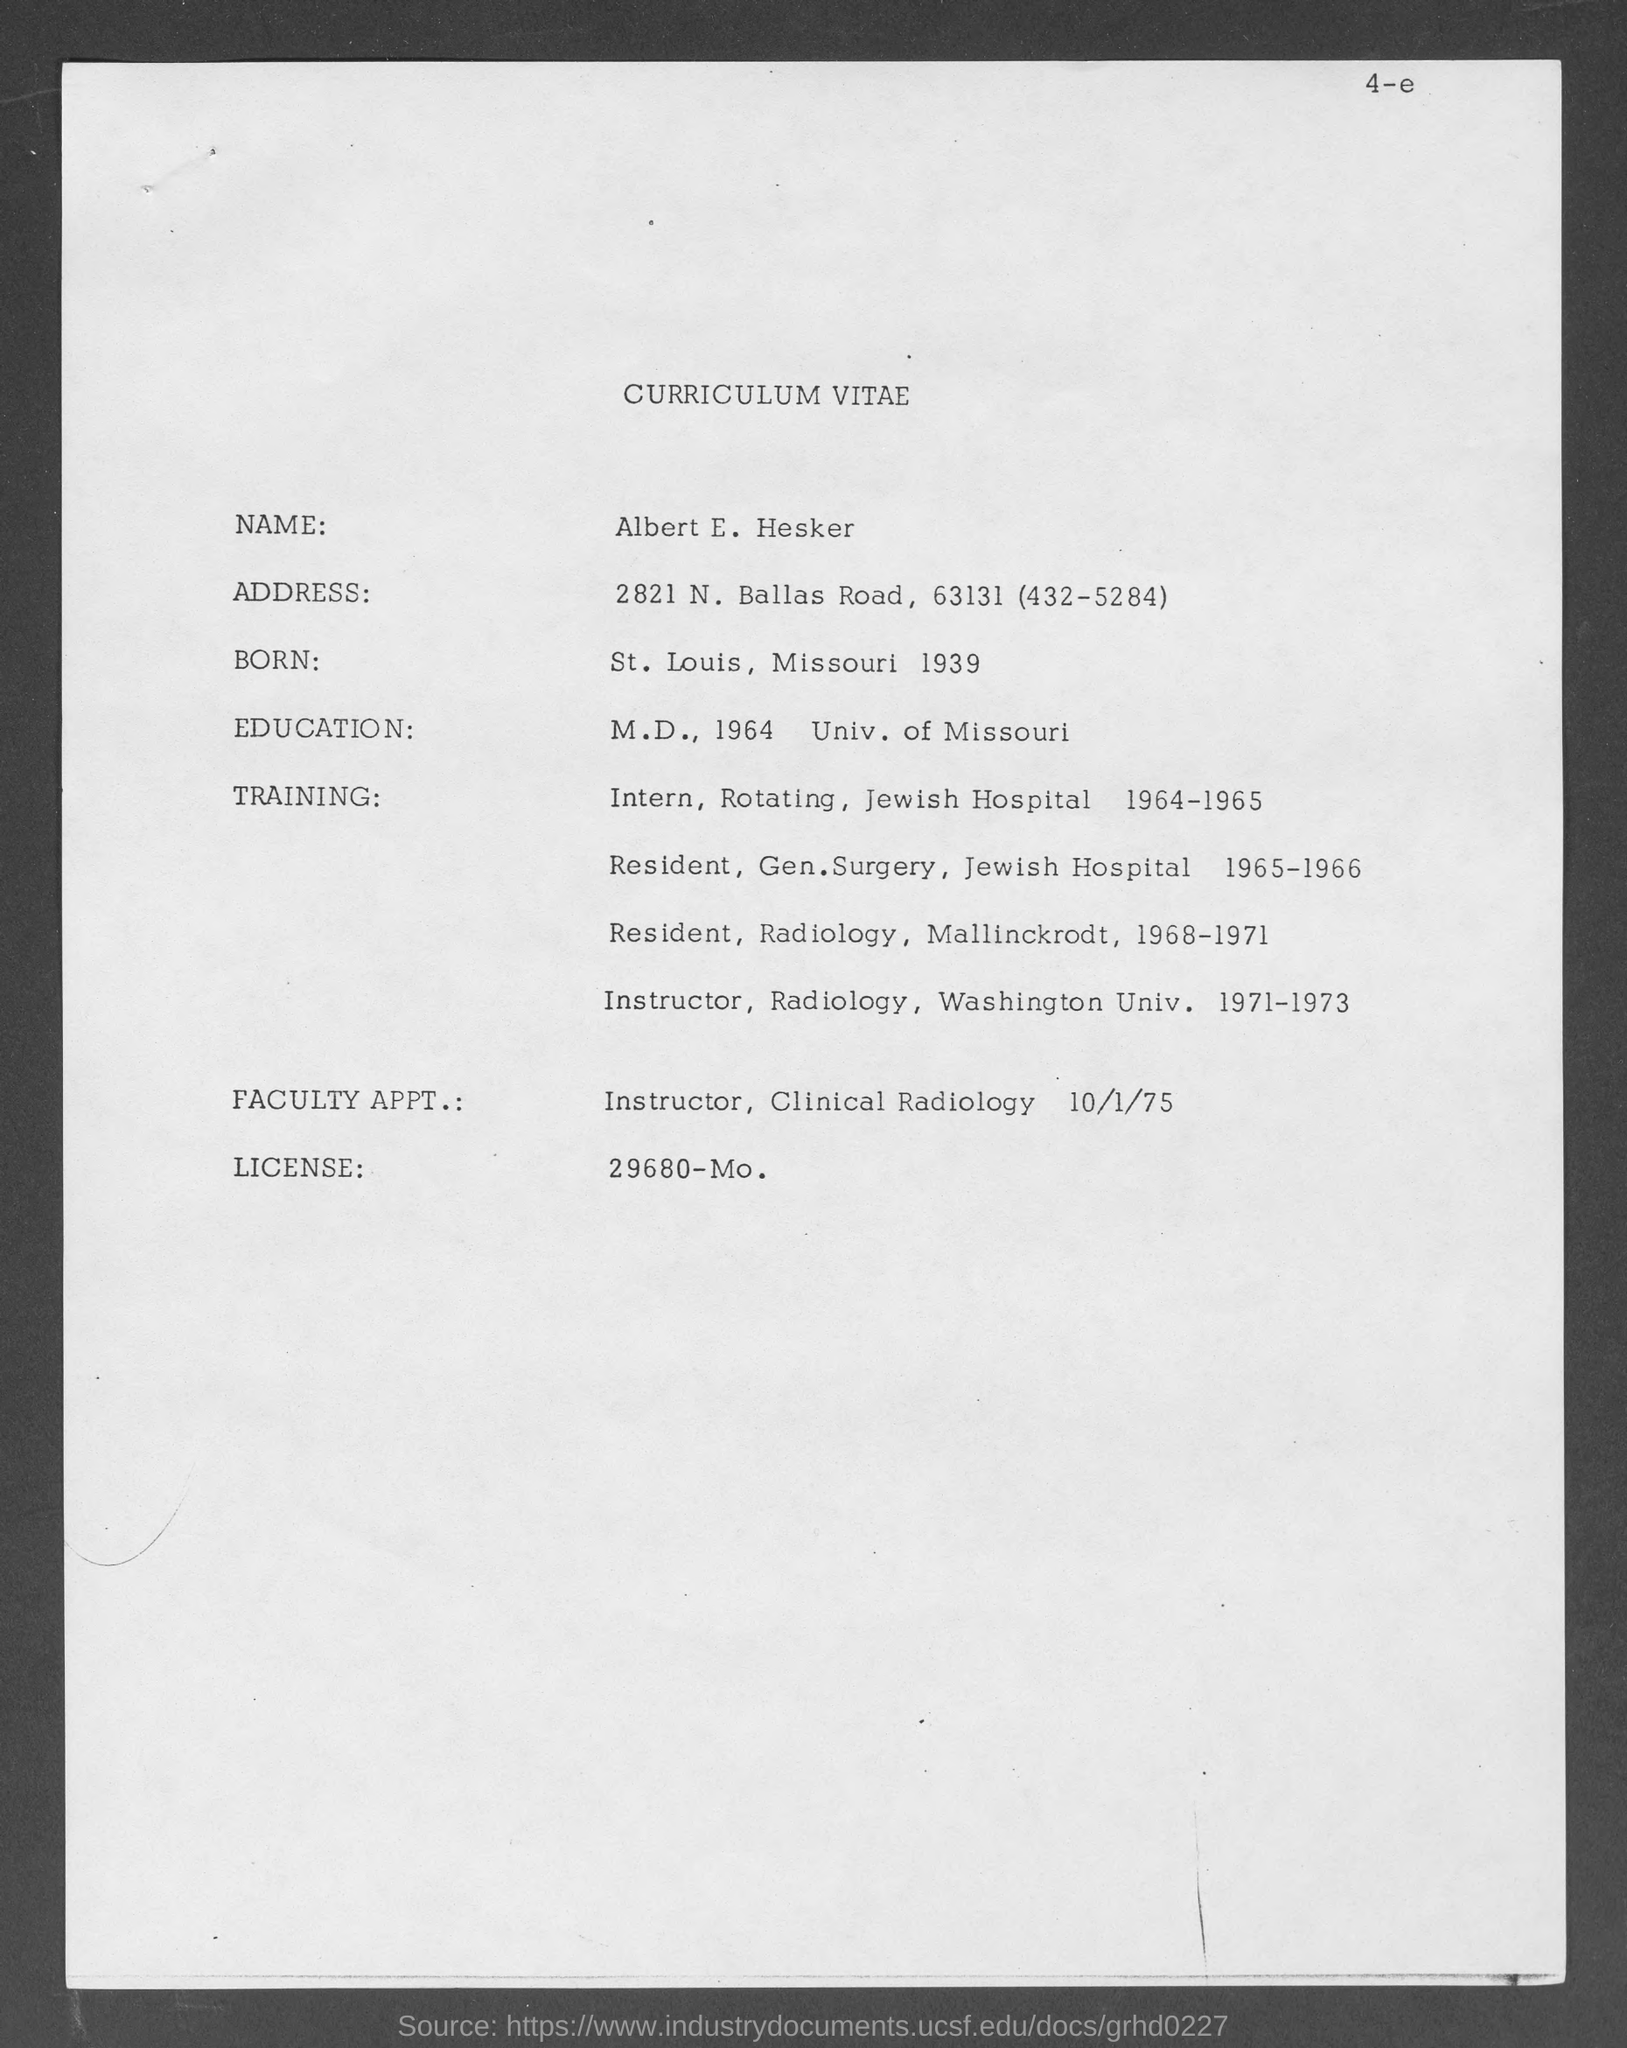Whose curriculum vitae is provided?
Provide a short and direct response. Albert E. Hesker. What is the educational qualification of Albert?
Make the answer very short. M. D., 1964 Univ. of Missouri. Which is the License No of Albert?
Offer a very short reply. 29680- Mo. 